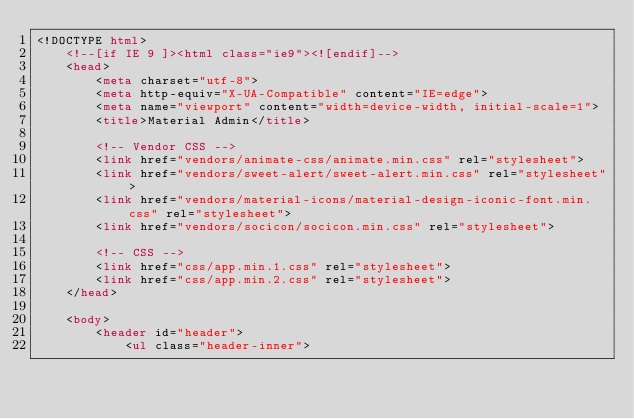Convert code to text. <code><loc_0><loc_0><loc_500><loc_500><_HTML_><!DOCTYPE html>
    <!--[if IE 9 ]><html class="ie9"><![endif]-->
    <head>
        <meta charset="utf-8">
        <meta http-equiv="X-UA-Compatible" content="IE=edge">
        <meta name="viewport" content="width=device-width, initial-scale=1">
        <title>Material Admin</title>
    
        <!-- Vendor CSS -->
        <link href="vendors/animate-css/animate.min.css" rel="stylesheet">
        <link href="vendors/sweet-alert/sweet-alert.min.css" rel="stylesheet">
        <link href="vendors/material-icons/material-design-iconic-font.min.css" rel="stylesheet">
        <link href="vendors/socicon/socicon.min.css" rel="stylesheet">
            
        <!-- CSS -->
        <link href="css/app.min.1.css" rel="stylesheet">
        <link href="css/app.min.2.css" rel="stylesheet">
    </head>
    
    <body>
        <header id="header">
            <ul class="header-inner"></code> 